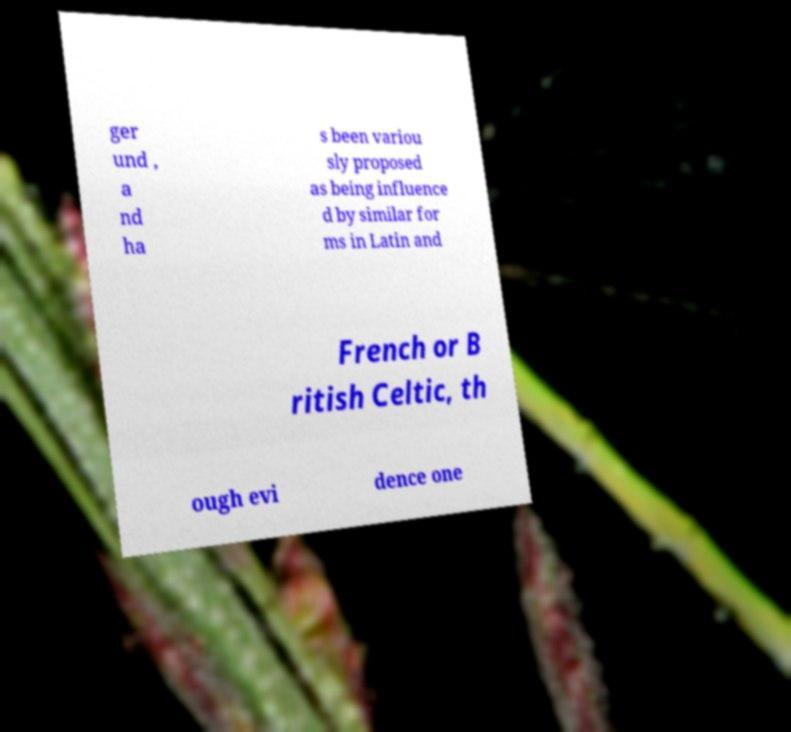Could you assist in decoding the text presented in this image and type it out clearly? ger und , a nd ha s been variou sly proposed as being influence d by similar for ms in Latin and French or B ritish Celtic, th ough evi dence one 